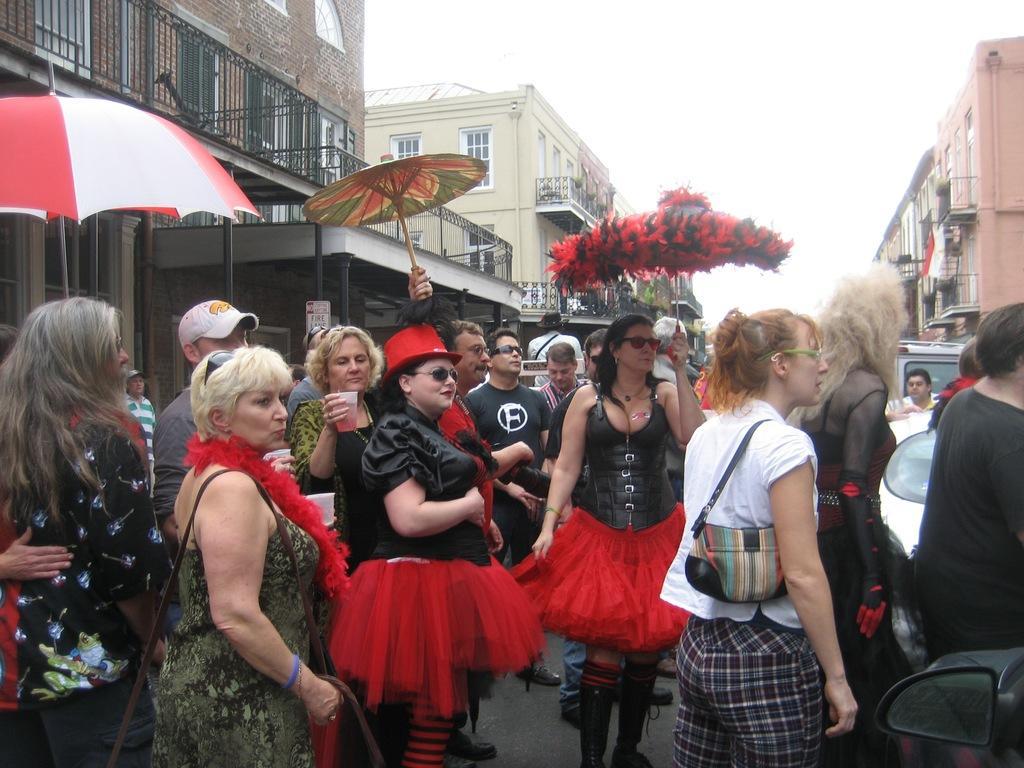How would you summarize this image in a sentence or two? In this image we can see a few people standing on the ground, among them some are holding objects, like the umbrellas and glasses, there are some buildings, vehicles, windows and grille, in the background we can see the sky. 